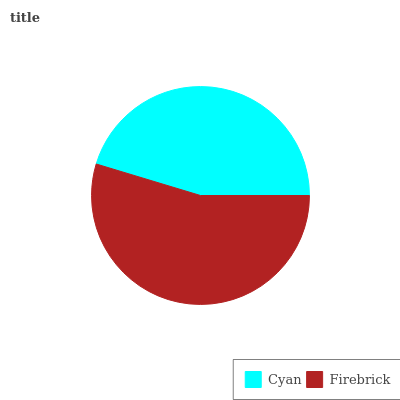Is Cyan the minimum?
Answer yes or no. Yes. Is Firebrick the maximum?
Answer yes or no. Yes. Is Firebrick the minimum?
Answer yes or no. No. Is Firebrick greater than Cyan?
Answer yes or no. Yes. Is Cyan less than Firebrick?
Answer yes or no. Yes. Is Cyan greater than Firebrick?
Answer yes or no. No. Is Firebrick less than Cyan?
Answer yes or no. No. Is Firebrick the high median?
Answer yes or no. Yes. Is Cyan the low median?
Answer yes or no. Yes. Is Cyan the high median?
Answer yes or no. No. Is Firebrick the low median?
Answer yes or no. No. 